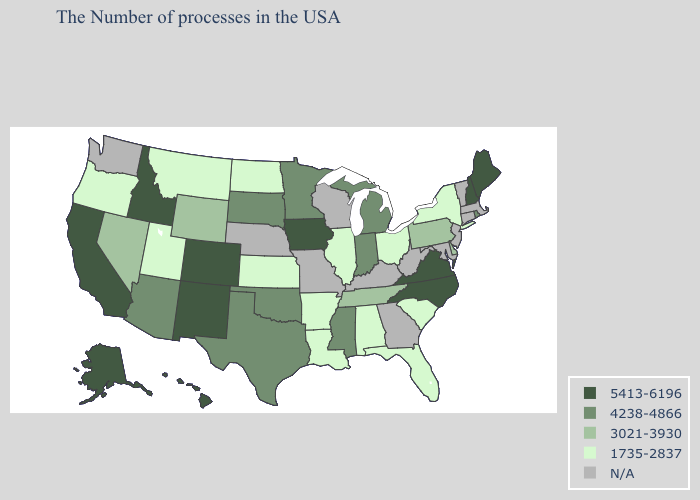Name the states that have a value in the range 4238-4866?
Be succinct. Rhode Island, Michigan, Indiana, Mississippi, Minnesota, Oklahoma, Texas, South Dakota, Arizona. What is the value of Alaska?
Give a very brief answer. 5413-6196. What is the lowest value in the West?
Answer briefly. 1735-2837. What is the value of Illinois?
Write a very short answer. 1735-2837. What is the lowest value in the USA?
Write a very short answer. 1735-2837. What is the lowest value in the USA?
Answer briefly. 1735-2837. What is the value of West Virginia?
Give a very brief answer. N/A. What is the value of Iowa?
Short answer required. 5413-6196. Name the states that have a value in the range 1735-2837?
Concise answer only. New York, South Carolina, Ohio, Florida, Alabama, Illinois, Louisiana, Arkansas, Kansas, North Dakota, Utah, Montana, Oregon. Among the states that border Nebraska , does South Dakota have the highest value?
Short answer required. No. What is the lowest value in the USA?
Answer briefly. 1735-2837. What is the highest value in the USA?
Keep it brief. 5413-6196. 